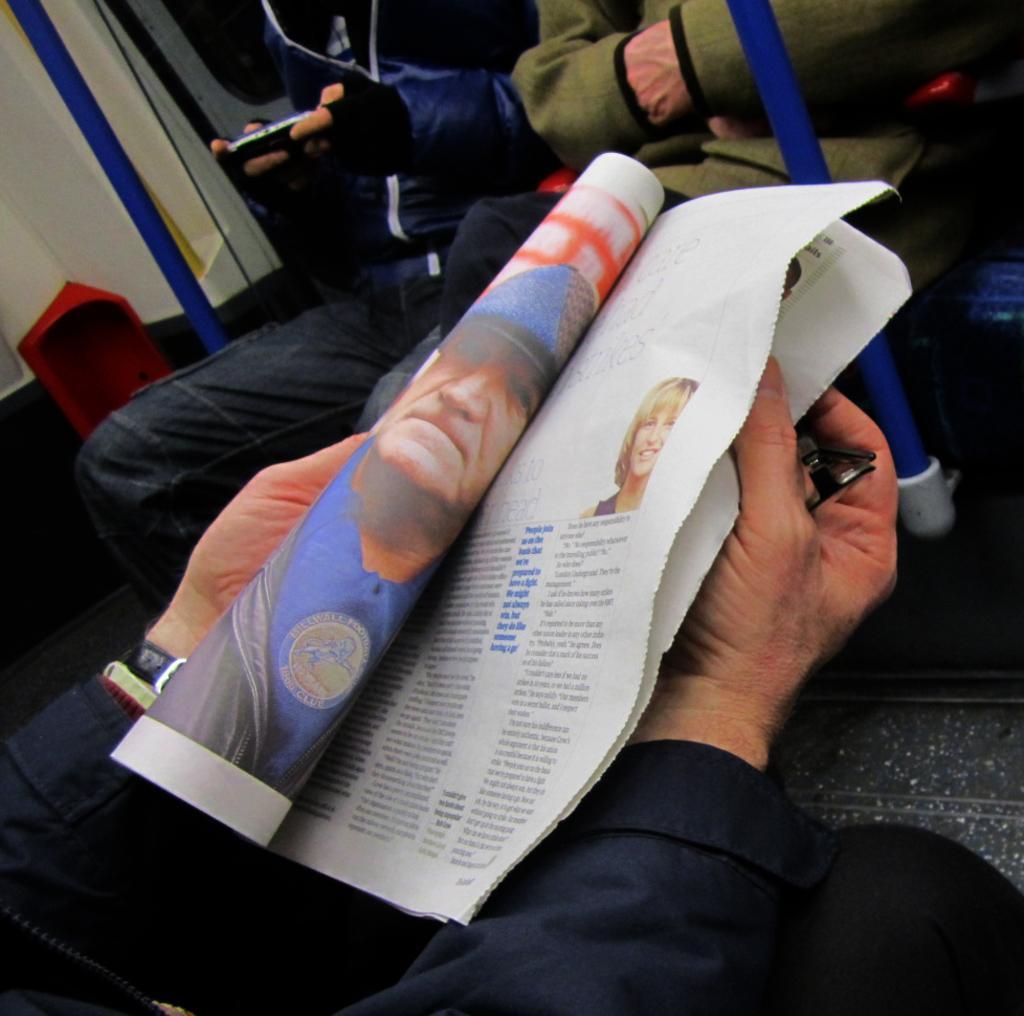Can you describe this image briefly? In this image, we can see human hands with paper and glasses. Top of the image, we can see two people are sitting. Here there are two blue rods, some red color object we can see. Here a person is holding some object. 